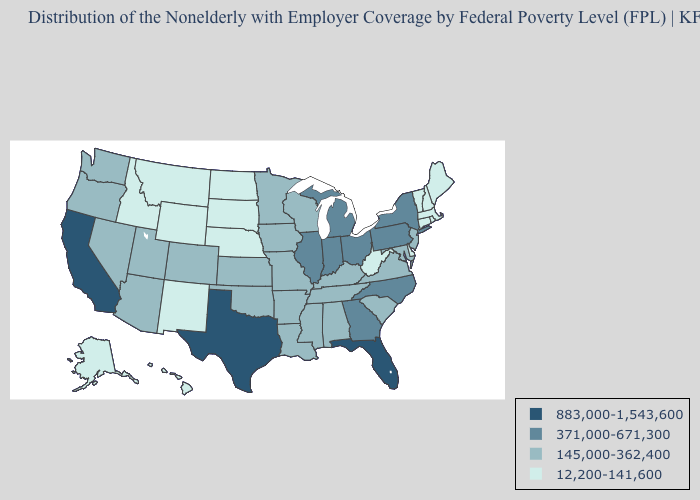Does West Virginia have the highest value in the South?
Concise answer only. No. Among the states that border North Carolina , which have the lowest value?
Answer briefly. South Carolina, Tennessee, Virginia. What is the value of Arkansas?
Answer briefly. 145,000-362,400. Does Tennessee have a lower value than Missouri?
Give a very brief answer. No. Which states have the lowest value in the USA?
Quick response, please. Alaska, Connecticut, Delaware, Hawaii, Idaho, Maine, Massachusetts, Montana, Nebraska, New Hampshire, New Mexico, North Dakota, Rhode Island, South Dakota, Vermont, West Virginia, Wyoming. How many symbols are there in the legend?
Answer briefly. 4. Which states have the lowest value in the USA?
Answer briefly. Alaska, Connecticut, Delaware, Hawaii, Idaho, Maine, Massachusetts, Montana, Nebraska, New Hampshire, New Mexico, North Dakota, Rhode Island, South Dakota, Vermont, West Virginia, Wyoming. What is the value of Mississippi?
Answer briefly. 145,000-362,400. What is the lowest value in the MidWest?
Concise answer only. 12,200-141,600. Does the first symbol in the legend represent the smallest category?
Be succinct. No. Name the states that have a value in the range 883,000-1,543,600?
Quick response, please. California, Florida, Texas. Which states have the lowest value in the South?
Keep it brief. Delaware, West Virginia. What is the value of Indiana?
Short answer required. 371,000-671,300. Does Arkansas have the same value as California?
Keep it brief. No. Name the states that have a value in the range 883,000-1,543,600?
Give a very brief answer. California, Florida, Texas. 